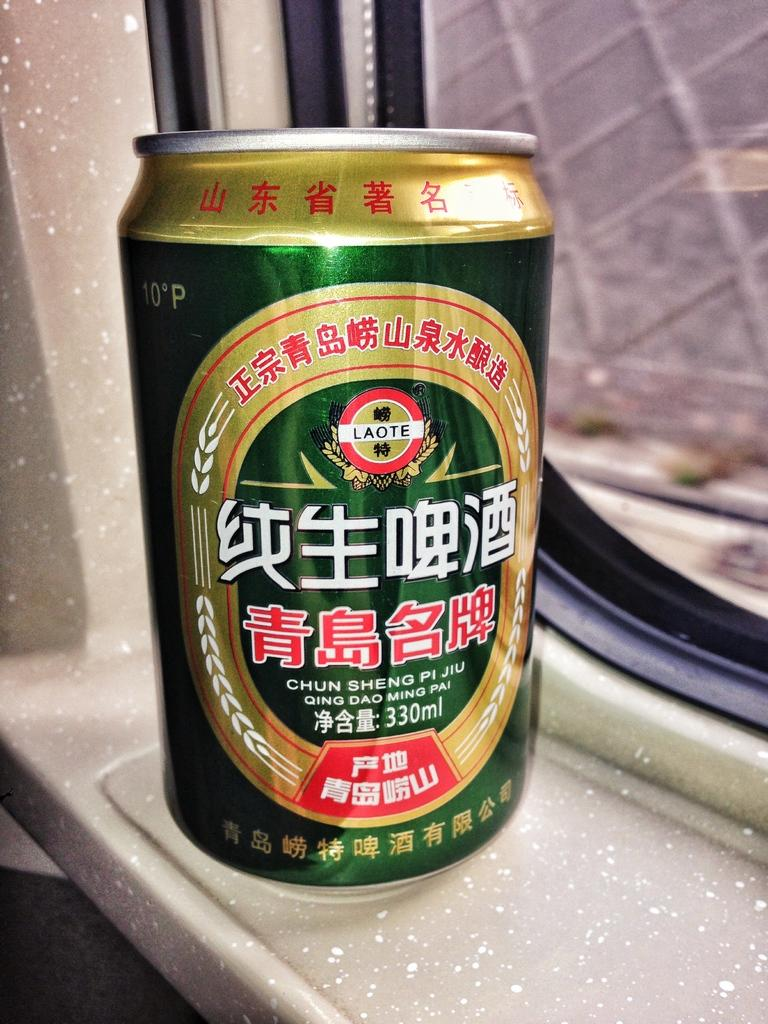<image>
Provide a brief description of the given image. Green and yellow can which says LAOTE on the top. 